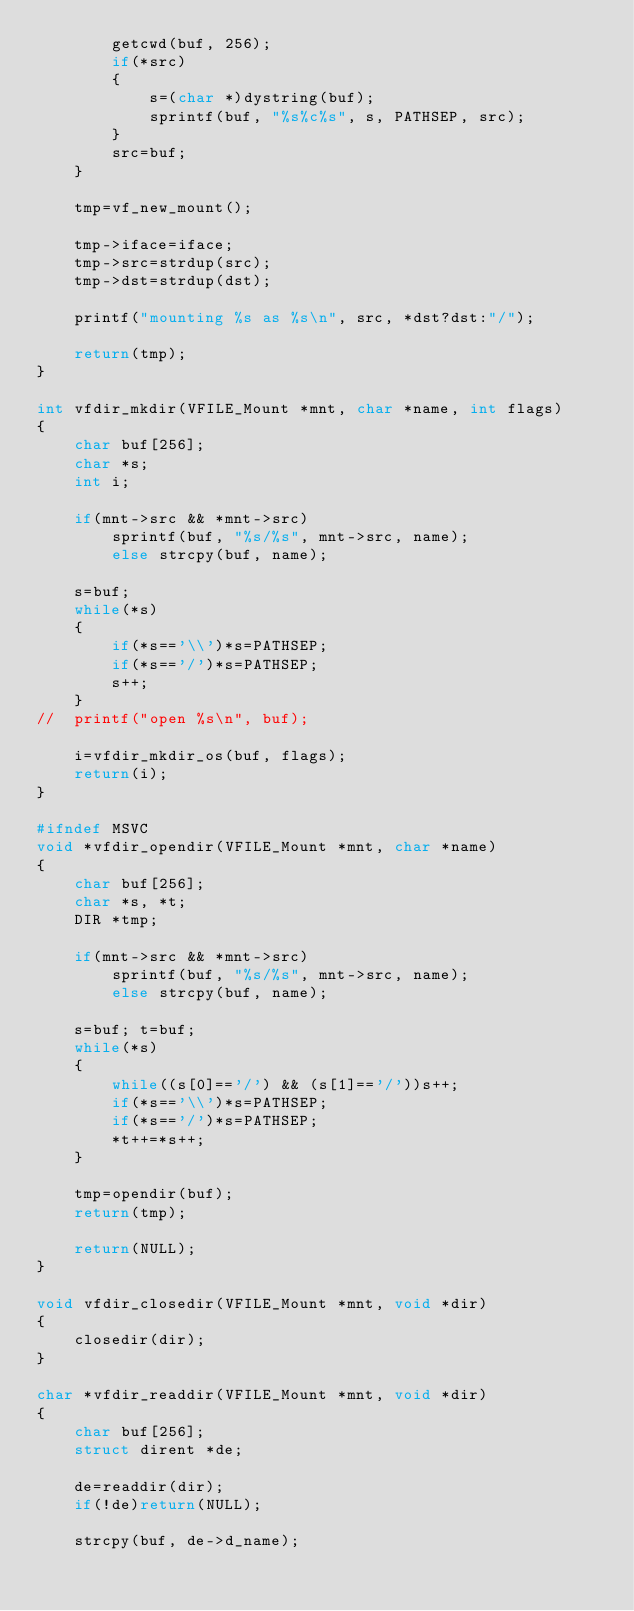<code> <loc_0><loc_0><loc_500><loc_500><_C_>		getcwd(buf, 256);
		if(*src)
		{
			s=(char *)dystring(buf);
			sprintf(buf, "%s%c%s", s, PATHSEP, src);
		}
		src=buf;
	}

	tmp=vf_new_mount();

	tmp->iface=iface;
	tmp->src=strdup(src);
	tmp->dst=strdup(dst);

	printf("mounting %s as %s\n", src, *dst?dst:"/");

	return(tmp);
}

int vfdir_mkdir(VFILE_Mount *mnt, char *name, int flags)
{
	char buf[256];
	char *s;
	int i;

	if(mnt->src && *mnt->src)
		sprintf(buf, "%s/%s", mnt->src, name);
		else strcpy(buf, name);

	s=buf;
	while(*s)
	{
		if(*s=='\\')*s=PATHSEP;
		if(*s=='/')*s=PATHSEP;
		s++;
	}
//	printf("open %s\n", buf);

	i=vfdir_mkdir_os(buf, flags);
	return(i);
}

#ifndef MSVC
void *vfdir_opendir(VFILE_Mount *mnt, char *name)
{
	char buf[256];
	char *s, *t;
	DIR *tmp;

	if(mnt->src && *mnt->src)
		sprintf(buf, "%s/%s", mnt->src, name);
		else strcpy(buf, name);

	s=buf; t=buf;
	while(*s)
	{
		while((s[0]=='/') && (s[1]=='/'))s++;
		if(*s=='\\')*s=PATHSEP;
		if(*s=='/')*s=PATHSEP;
		*t++=*s++;
	}

	tmp=opendir(buf);
	return(tmp);

	return(NULL);
}

void vfdir_closedir(VFILE_Mount *mnt, void *dir)
{
	closedir(dir);
}

char *vfdir_readdir(VFILE_Mount *mnt, void *dir)
{
	char buf[256];
	struct dirent *de;

	de=readdir(dir);
	if(!de)return(NULL);

	strcpy(buf, de->d_name);</code> 